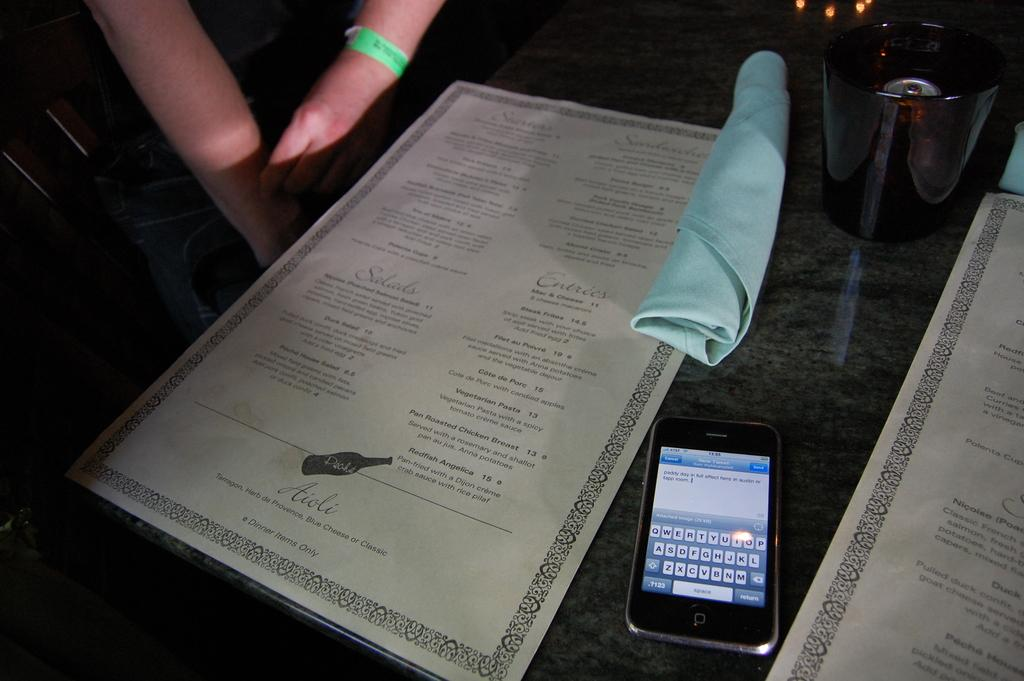What is located at the bottom of the image? There is a table at the bottom of the image. What items can be seen on the table? There are papers, a cloth, a glass, and a mobile phone on the table. What is the person in the image doing? The person is sitting behind the table. Can you describe the pain the person is experiencing in the image? There is no indication of pain in the image; the person is sitting behind the table. Where is the playground located in the image? There is no playground present in the image. 